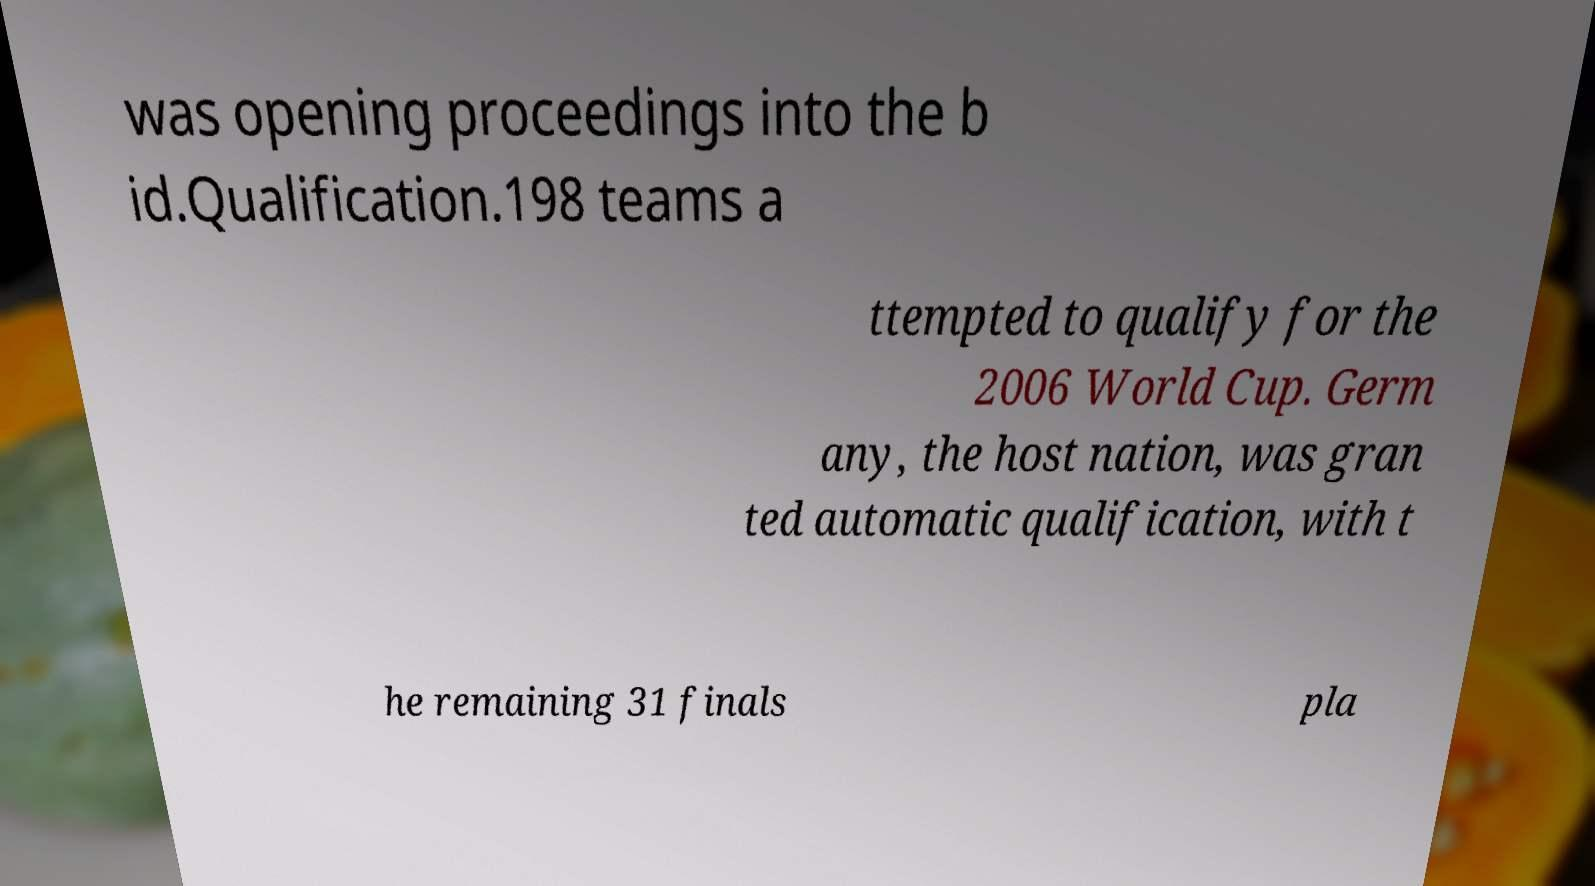Please identify and transcribe the text found in this image. was opening proceedings into the b id.Qualification.198 teams a ttempted to qualify for the 2006 World Cup. Germ any, the host nation, was gran ted automatic qualification, with t he remaining 31 finals pla 